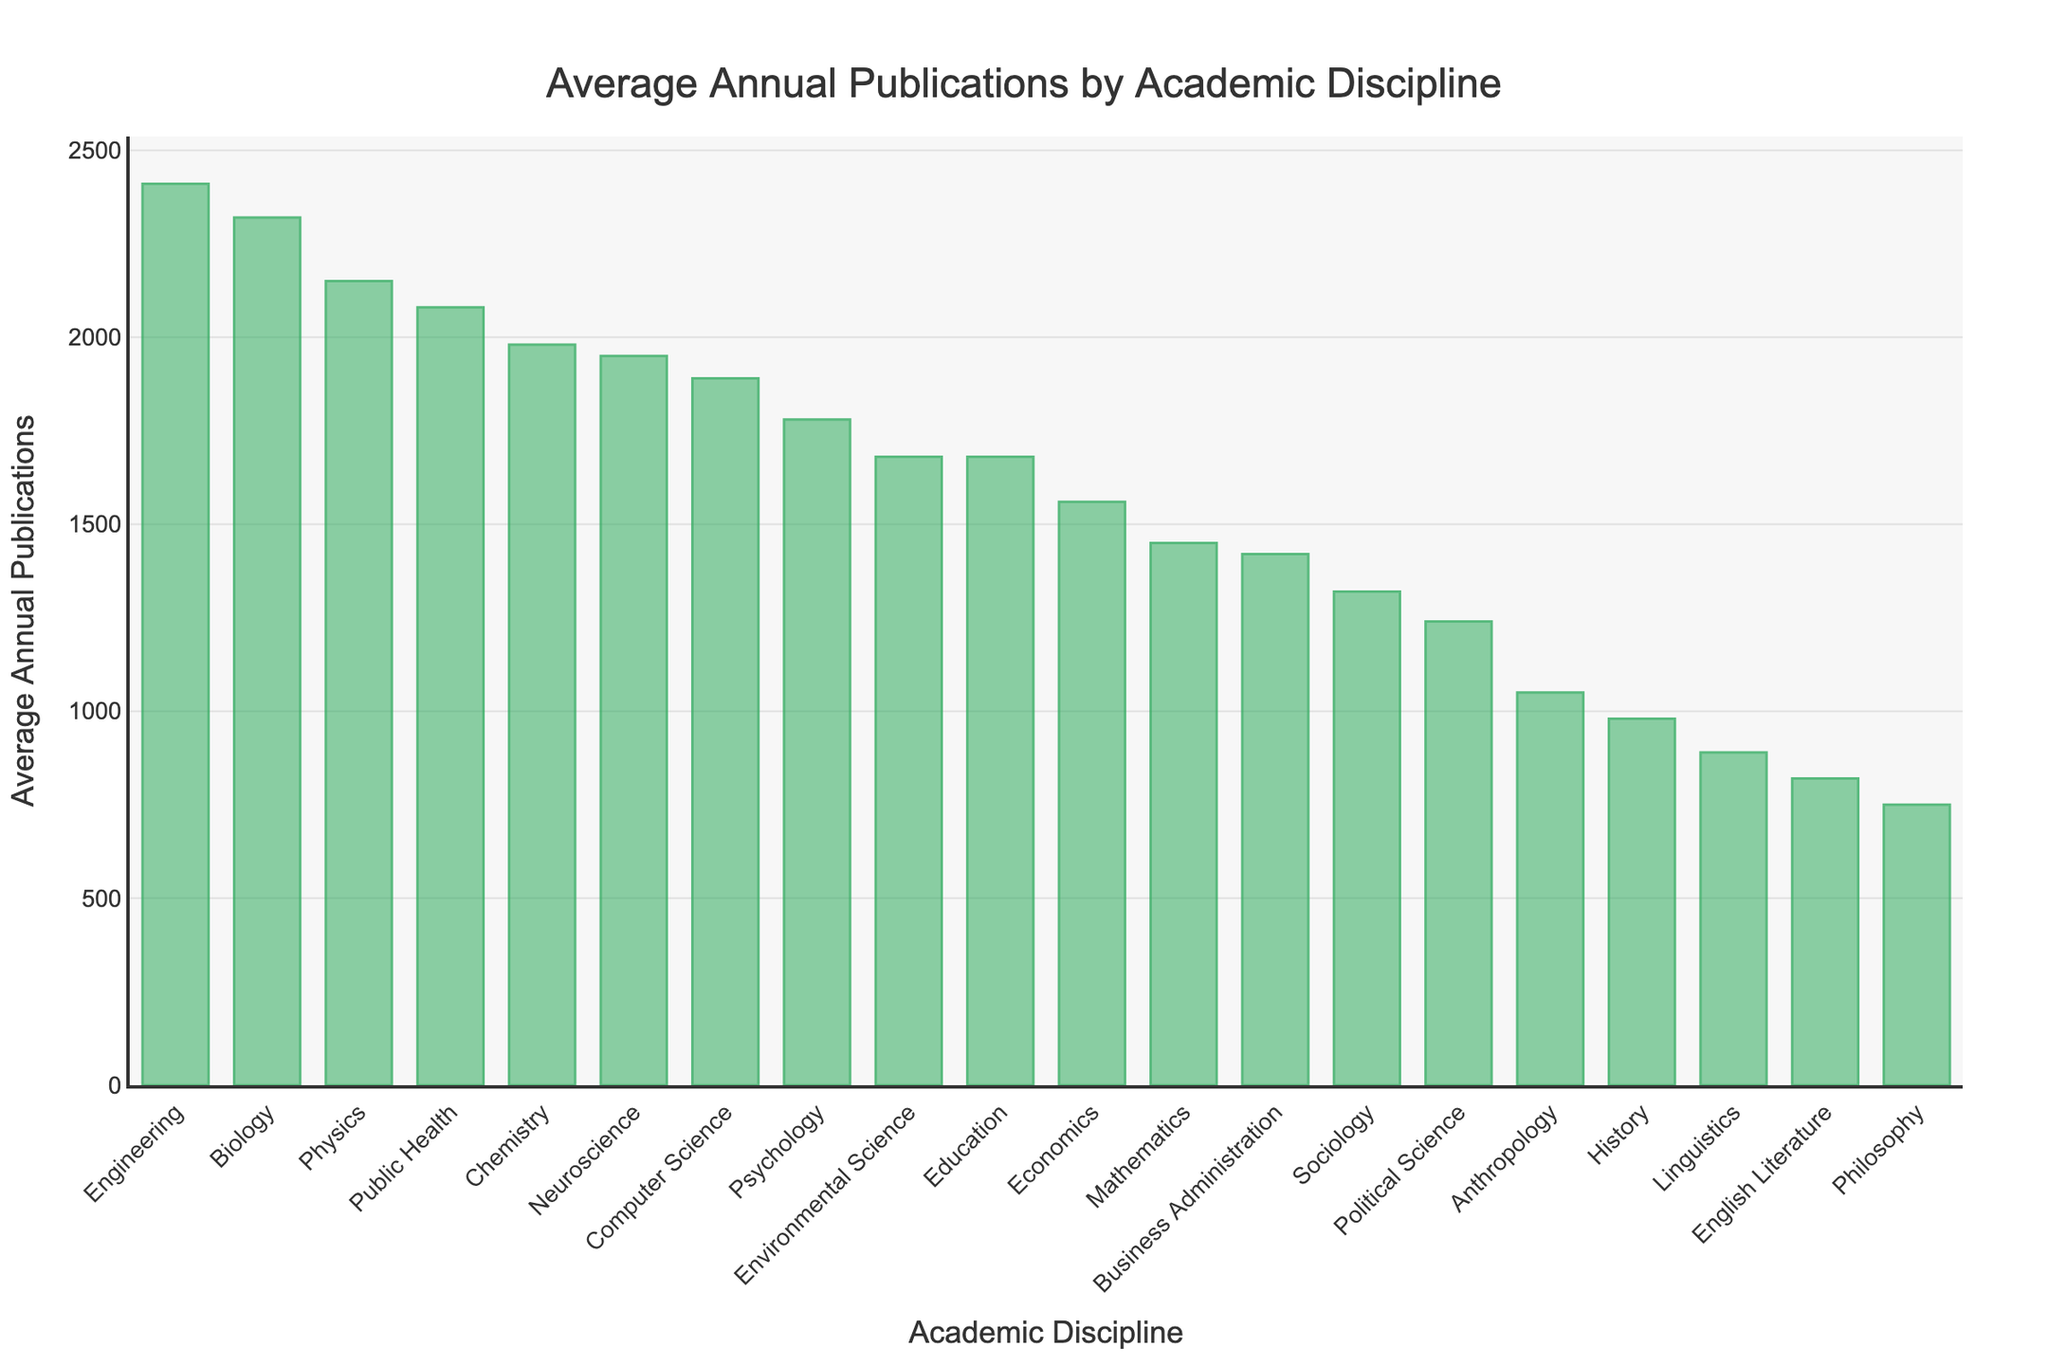How many more annual publications does Biology have compared to Chemistry? Biology has 2320 annual publications and Chemistry has 1980. The difference is calculated by subtracting Chemistry's publications from Biology's: 2320 - 1980 = 340
Answer: 340 Which discipline has the highest average annual publications, and what is the value? By examining the figure, Engineering is the discipline with the highest average annual publications at 2410
Answer: Engineering, 2410 List the disciplines with fewer than 1000 average annual publications. From the figure, History, English Literature, Philosophy, Linguistics, and Anthropology have fewer than 1000 annual publications
Answer: History, English Literature, Philosophy, Linguistics, Anthropology What is the average number of annual publications for Computer Science and Neuroscience combined? Computer Science has 1890 publications and Neuroscience has 1950. The combined average is calculated by (1890 + 1950) / 2 = 1920
Answer: 1920 Which has more publications: Public Health or Education? By observing the figure, Public Health has 2080 publications compared to Education's 1680
Answer: Public Health What is the total number of publications for Economics, Sociology, and Political Science? Economics has 1560, Sociology has 1320, and Political Science has 1240. Summing them gives 1560 + 1320 + 1240 = 4120
Answer: 4120 Are there more publications in Sociology or Philosophy? By referring to the figure, Sociology has 1320 publications and Philosophy has 750
Answer: Sociology Rank the top three disciplines by their average annual publications. From the figure, the top three disciplines in descending order are: 1. Engineering (2410), 2. Biology (2320), 3. Physics (2150)
Answer: 1. Engineering, 2. Biology, 3. Physics What is the median value of the average annual publications across all disciplines? Listing all publication values in ascending order: 750, 820, 890, 980, 1050, 1240, 1320, 1420, 1450, 1560, 1680, 1680, 1780, 1890, 1950, 1980, 2080, 2150, 2320, 2410. The median (middle value in the sorted list) is the average of the 10th and 11th values: (1560 + 1680) / 2 = 1620
Answer: 1620 